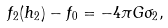Convert formula to latex. <formula><loc_0><loc_0><loc_500><loc_500>f _ { 2 } ( h _ { 2 } ) - f _ { 0 } = - 4 \pi G \sigma _ { 2 } ,</formula> 